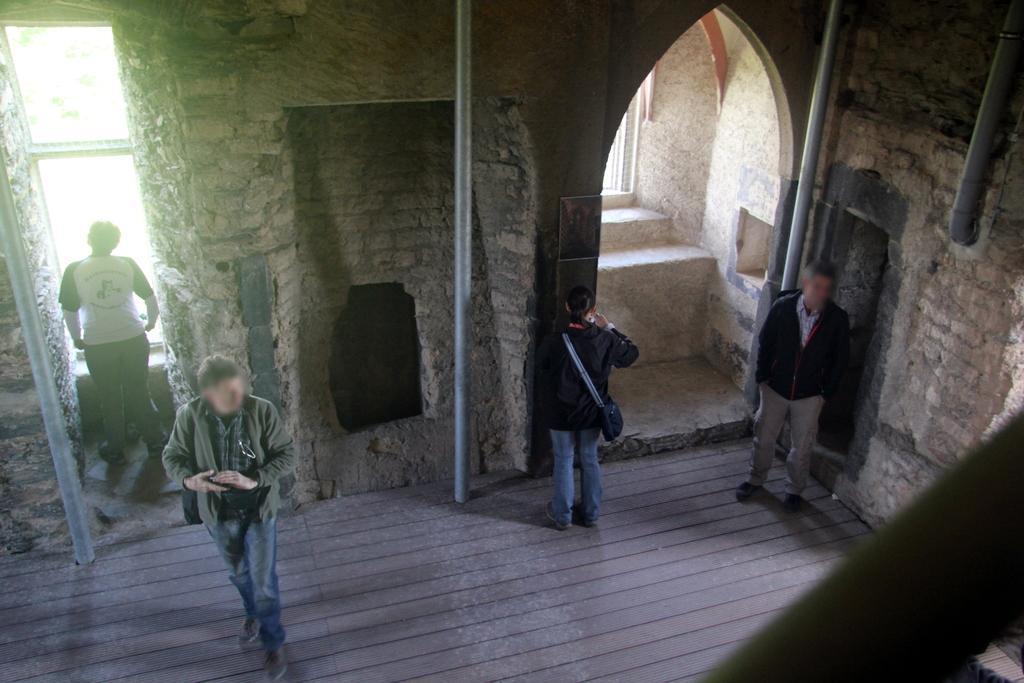How would you summarize this image in a sentence or two? This picture is clicked inside a fort. There are few people standing. There are poles and pipelines. In the background there are windows and wall.  